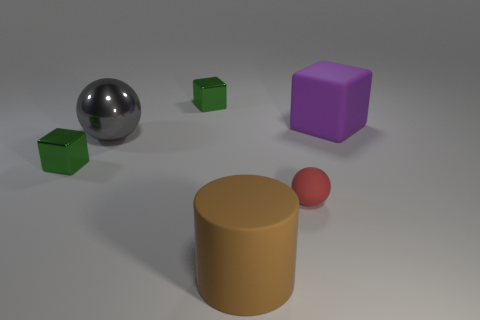Subtract all gray balls. How many green cubes are left? 2 Subtract all big matte blocks. How many blocks are left? 2 Add 1 matte cylinders. How many objects exist? 7 Subtract all cylinders. How many objects are left? 5 Subtract all tiny blue matte cubes. Subtract all big brown matte objects. How many objects are left? 5 Add 1 big purple things. How many big purple things are left? 2 Add 6 purple matte cubes. How many purple matte cubes exist? 7 Subtract 0 red blocks. How many objects are left? 6 